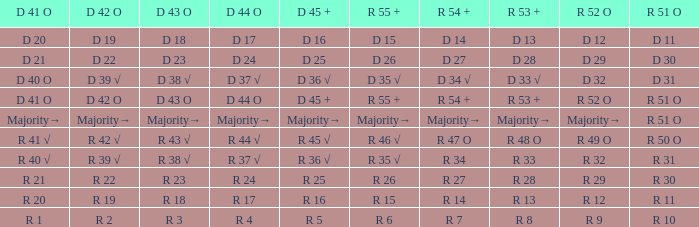Parse the full table. {'header': ['D 41 O', 'D 42 O', 'D 43 O', 'D 44 O', 'D 45 +', 'R 55 +', 'R 54 +', 'R 53 +', 'R 52 O', 'R 51 O'], 'rows': [['D 20', 'D 19', 'D 18', 'D 17', 'D 16', 'D 15', 'D 14', 'D 13', 'D 12', 'D 11'], ['D 21', 'D 22', 'D 23', 'D 24', 'D 25', 'D 26', 'D 27', 'D 28', 'D 29', 'D 30'], ['D 40 O', 'D 39 √', 'D 38 √', 'D 37 √', 'D 36 √', 'D 35 √', 'D 34 √', 'D 33 √', 'D 32', 'D 31'], ['D 41 O', 'D 42 O', 'D 43 O', 'D 44 O', 'D 45 +', 'R 55 +', 'R 54 +', 'R 53 +', 'R 52 O', 'R 51 O'], ['Majority→', 'Majority→', 'Majority→', 'Majority→', 'Majority→', 'Majority→', 'Majority→', 'Majority→', 'Majority→', 'R 51 O'], ['R 41 √', 'R 42 √', 'R 43 √', 'R 44 √', 'R 45 √', 'R 46 √', 'R 47 O', 'R 48 O', 'R 49 O', 'R 50 O'], ['R 40 √', 'R 39 √', 'R 38 √', 'R 37 √', 'R 36 √', 'R 35 √', 'R 34', 'R 33', 'R 32', 'R 31'], ['R 21', 'R 22', 'R 23', 'R 24', 'R 25', 'R 26', 'R 27', 'R 28', 'R 29', 'R 30'], ['R 20', 'R 19', 'R 18', 'R 17', 'R 16', 'R 15', 'R 14', 'R 13', 'R 12', 'R 11'], ['R 1', 'R 2', 'R 3', 'R 4', 'R 5', 'R 6', 'R 7', 'R 8', 'R 9', 'R 10']]} What r 51 o value correlates to a d 42 o value of r 19? R 11. 